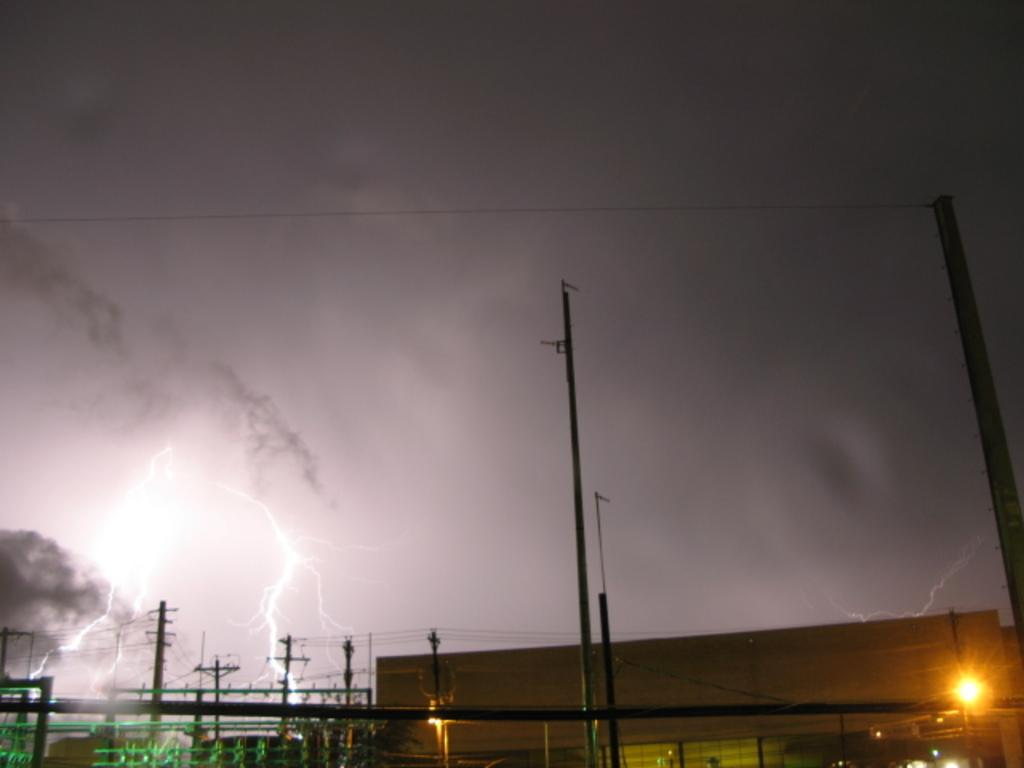What can be seen in the sky in the image? The sky is visible in the image, and there are clouds in the sky. What weather phenomenon is depicted in the image? There is lightning in the image. What structures are present in the image? Electric poles, buildings, and electric lights are present in the image. What else can be seen related to electricity in the image? Electric cables are visible in the image. What type of feast is being prepared in the image? There is no indication of a feast being prepared in the image; it primarily focuses on the sky and electrical elements. Can you see a crate in the image? There is no crate present in the image. 